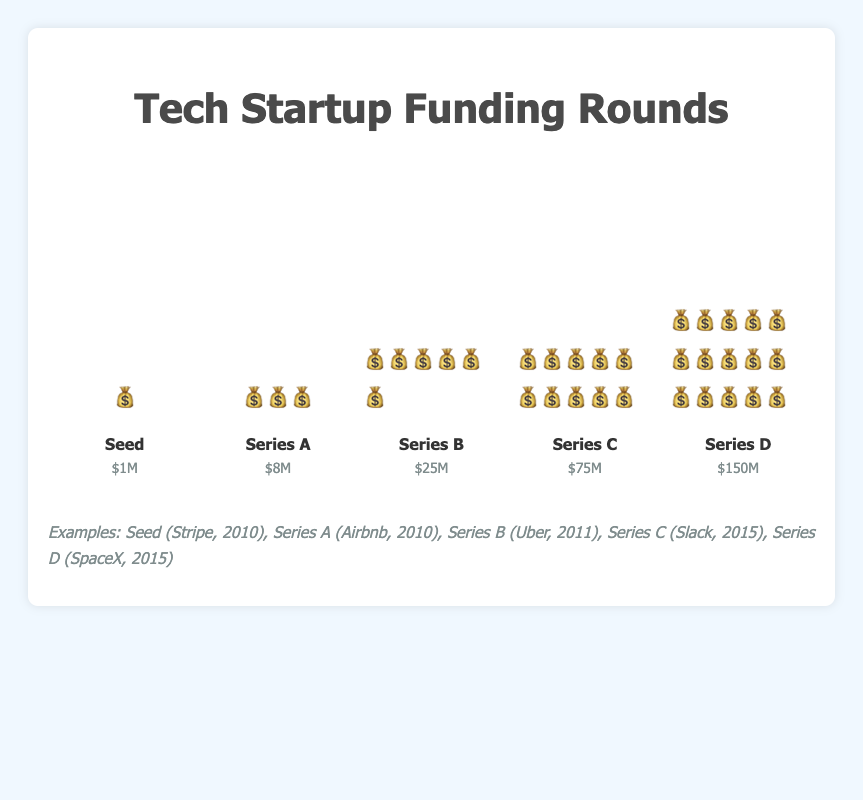What's the title of the chart? The title is displayed at the top in larger and bold font.
Answer: Tech Startup Funding Rounds How many stages of funding are represented in the chart? The chart shows data for 5 stages: Seed, Series A, Series B, Series C, and Series D.
Answer: 5 Which stage has the highest funding represented by the most emoji? By counting the money bag emojis, Series D has the most with 15 emojis.
Answer: Series D What is the total funding amount for Series A and Series B combined? Series A has $8M and Series B has $25M. Adding them gives $33M.
Answer: $33M Which stage has the least amount of funding? By checking the smallest height of the bar and counting the emoji, Seed stage has the least funding represented by 1 emoji.
Answer: Seed By how much does the funding amount increase from Series B to Series C? Series C has $75M and Series B has $25M. The difference is $75M - $25M = $50M.
Answer: $50M Name an example company that had a Series A funding round. The examples section lists Airbnb as a company with a Series A funding in 2010.
Answer: Airbnb How many emojis represent the funding for the Series C stage? By counting the emojis for Series C, there are 10 money bag emojis.
Answer: 10 What’s the average emoji count per stage for all funding rounds? The total emoji counts are 1 + 3 + 6 + 10 + 15 = 35 emojis. There are 5 stages, so the average is 35/5 = 7.
Answer: 7 Which funding stage saw the largest single increase in emoji count compared to its previous stage? Comparing the increases: Seed to Series A (2 more), Series A to Series B (3 more), Series B to Series C (4 more), and Series C to Series D (5 more); Series C to Series D has the largest increase with 5 more emojis.
Answer: Series C to Series D 